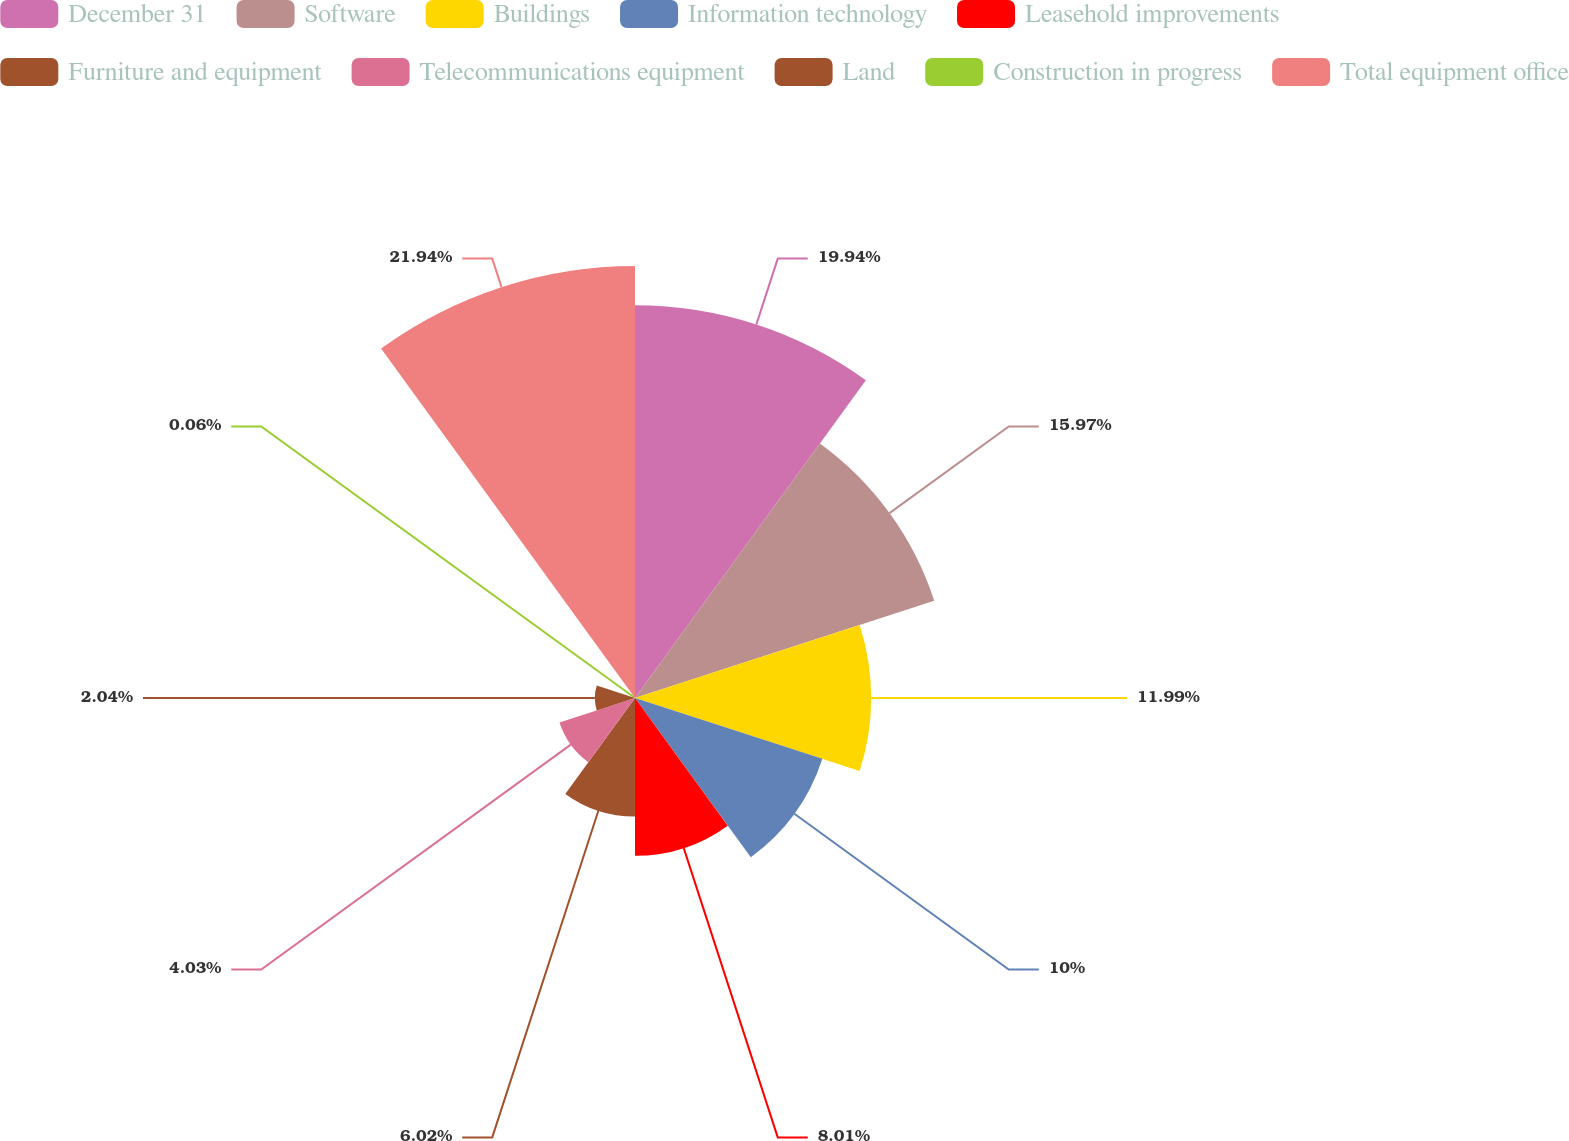Convert chart to OTSL. <chart><loc_0><loc_0><loc_500><loc_500><pie_chart><fcel>December 31<fcel>Software<fcel>Buildings<fcel>Information technology<fcel>Leasehold improvements<fcel>Furniture and equipment<fcel>Telecommunications equipment<fcel>Land<fcel>Construction in progress<fcel>Total equipment office<nl><fcel>19.94%<fcel>15.97%<fcel>11.99%<fcel>10.0%<fcel>8.01%<fcel>6.02%<fcel>4.03%<fcel>2.04%<fcel>0.06%<fcel>21.93%<nl></chart> 